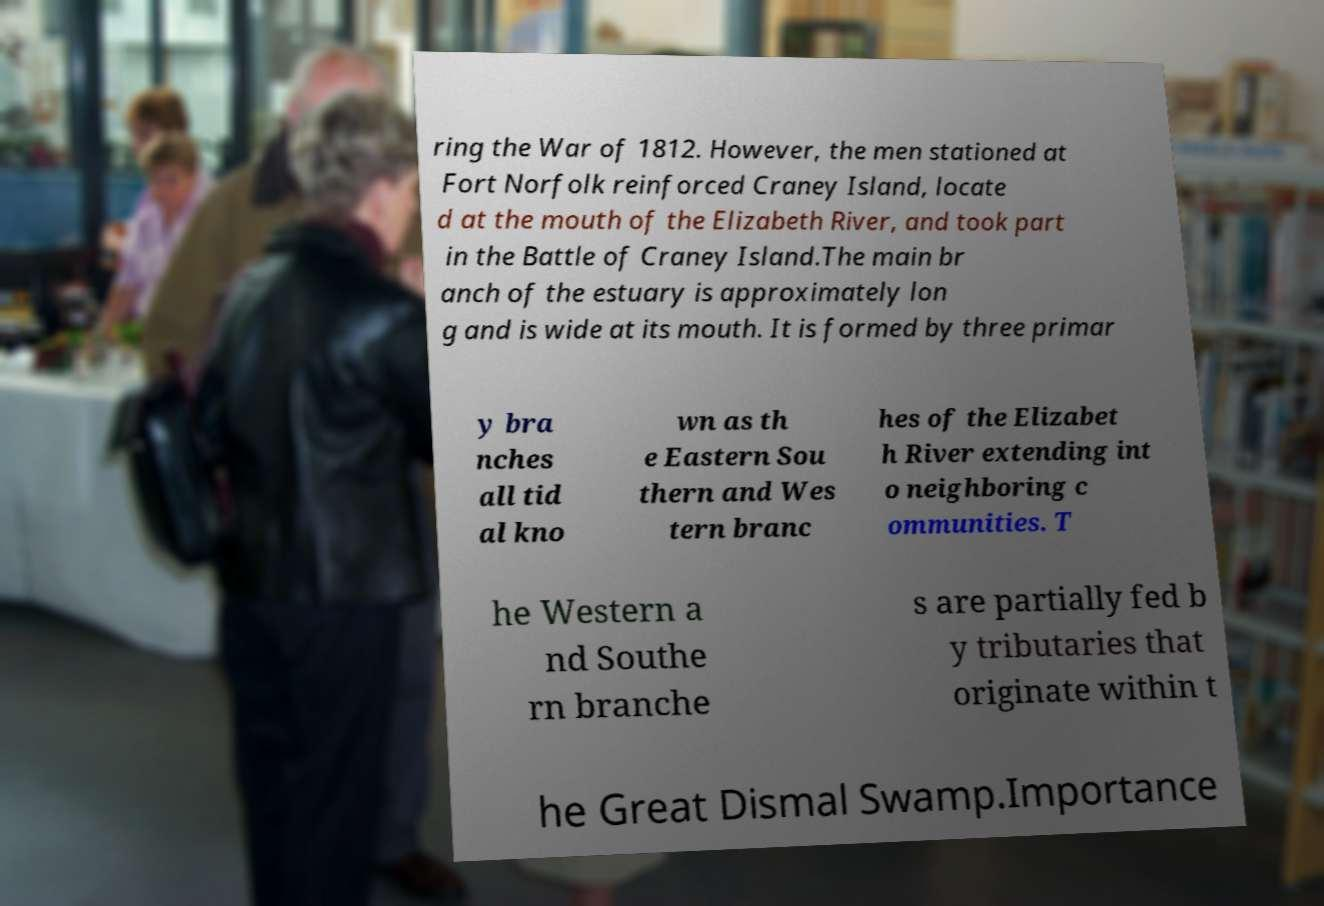Please identify and transcribe the text found in this image. ring the War of 1812. However, the men stationed at Fort Norfolk reinforced Craney Island, locate d at the mouth of the Elizabeth River, and took part in the Battle of Craney Island.The main br anch of the estuary is approximately lon g and is wide at its mouth. It is formed by three primar y bra nches all tid al kno wn as th e Eastern Sou thern and Wes tern branc hes of the Elizabet h River extending int o neighboring c ommunities. T he Western a nd Southe rn branche s are partially fed b y tributaries that originate within t he Great Dismal Swamp.Importance 